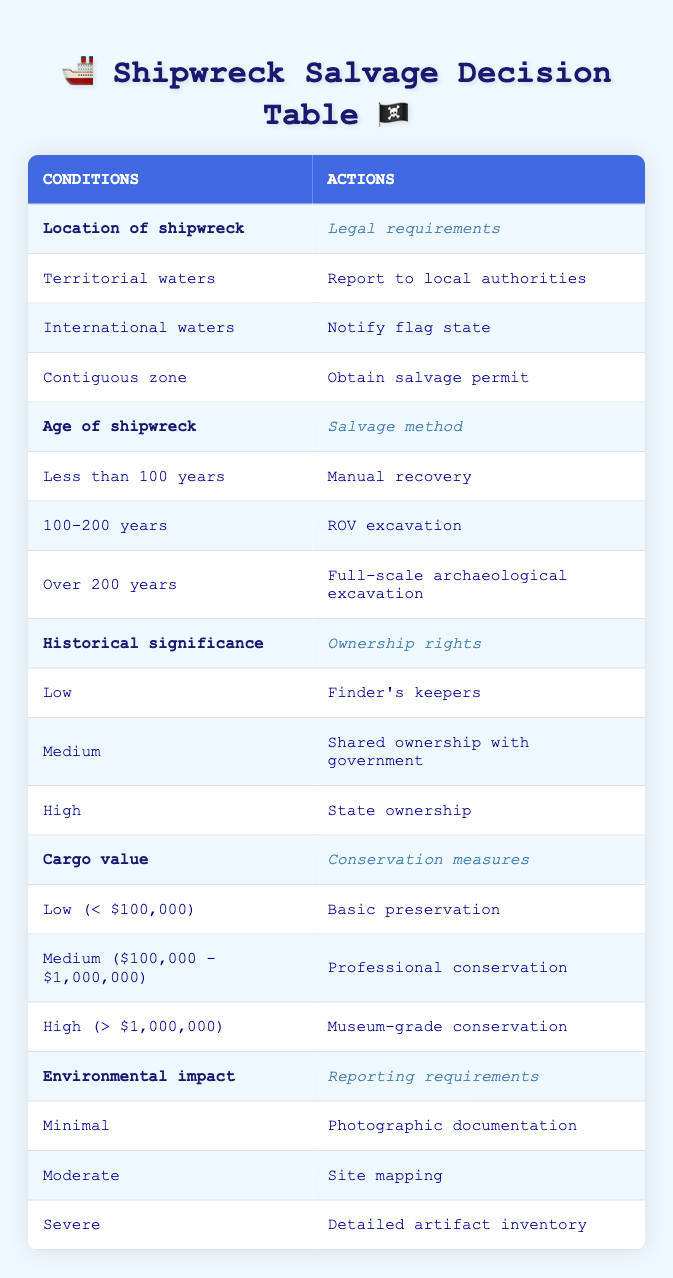What legal requirement should be followed if the shipwreck is found in international waters? According to the table, if the location of the shipwreck is in international waters, the legal requirement is to notify the flag state. This is found in the row corresponding to international waters.
Answer: Notify flag state What actions should be taken for a shipwreck that is over 200 years old? The salvage method for a shipwreck over 200 years old is full-scale archaeological excavation, as indicated in the row for "Over 200 years" under age.
Answer: Full-scale archaeological excavation Is it true that cargo valued over $1,000,000 requires museum-grade conservation? Yes, the table shows that cargo with a high value (over $1,000,000) necessitates museum-grade conservation. This is explicitly stated in the row corresponding to the high cargo value.
Answer: Yes What are the reporting requirements if the environmental impact is moderate? If the environmental impact is moderate, the reporting requirement is to perform site mapping, as indicated in the row for "Moderate" under environmental impact.
Answer: Site mapping For a shipwreck with high historical significance, what are the ownership rights? The table indicates that for a shipwreck with high historical significance, the ownership rights are categorized as state ownership. This is represented in the row for "High" under historical significance.
Answer: State ownership If a shipwreck is found in territorial waters with a low cargo value, what conservation measures should be taken? For a shipwreck found in territorial waters and having a low cargo value (less than $100,000), the conservation measures required are basic preservation. This is indicated in the table under the row for low cargo value.
Answer: Basic preservation What is the average cargo value classification for a shipwreck considered to have medium historical significance? The average classification for cargo value associated with medium historical significance is medium, which is between $100,000 and $1,000,000. The related rows show that this category is shared with government in terms of ownership rights.
Answer: Medium Do shipwrecks with severe environmental impact require no reporting? No, for severe environmental impact, the table specifies that detailed artifact inventory is required, indicating that reporting is indeed necessary.
Answer: No What actions should be taken if a shipwreck in the contiguous zone has high historical significance? For a shipwreck in the contiguous zone, the legal requirement is to obtain a salvage permit, and with high historical significance, the ownership rights fall under state ownership. Therefore, both actions are relevant: obtaining a salvage permit and recognizing state ownership.
Answer: Obtain salvage permit and state ownership 